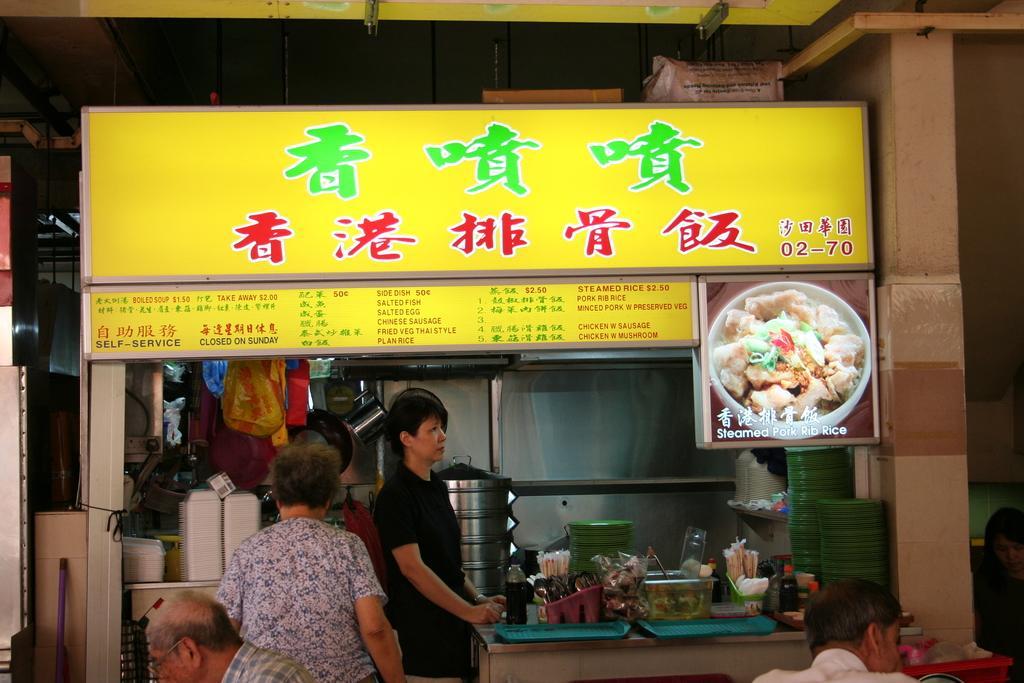Please provide a concise description of this image. In this image there are four persons, there is a table on that table there are some items, in the background there is a shop. 